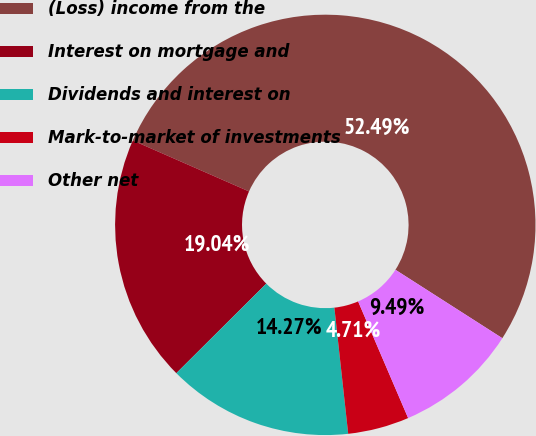Convert chart to OTSL. <chart><loc_0><loc_0><loc_500><loc_500><pie_chart><fcel>(Loss) income from the<fcel>Interest on mortgage and<fcel>Dividends and interest on<fcel>Mark-to-market of investments<fcel>Other net<nl><fcel>52.48%<fcel>19.04%<fcel>14.27%<fcel>4.71%<fcel>9.49%<nl></chart> 